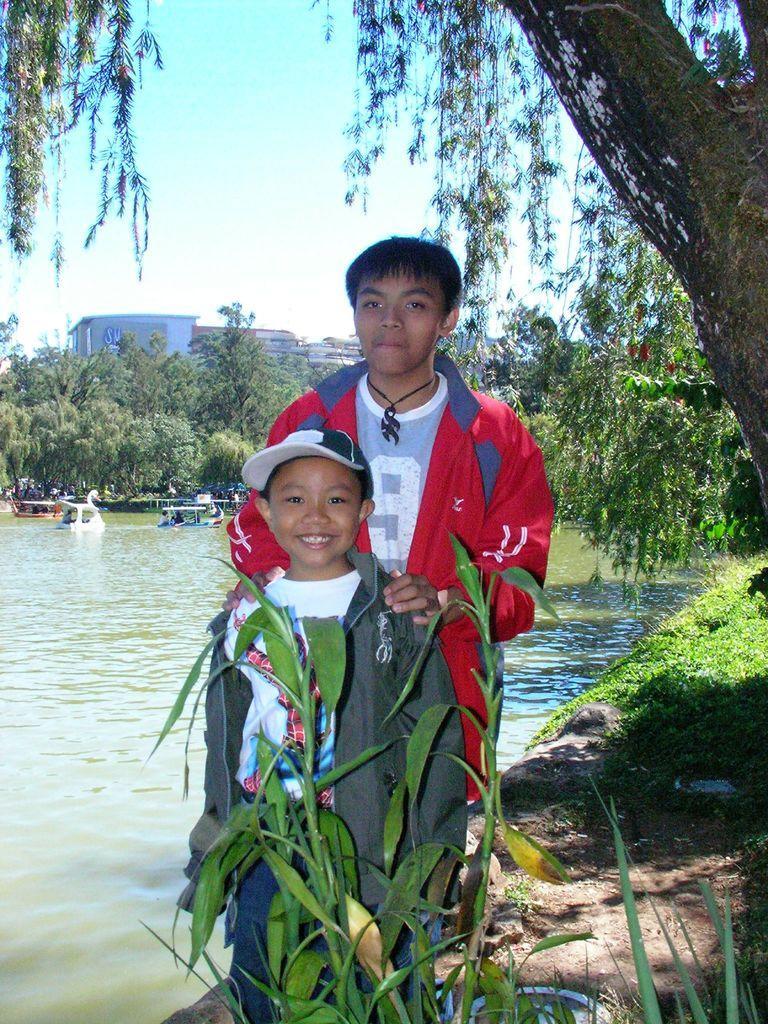Could you give a brief overview of what you see in this image? In the picture we can see two boys are standing together and one boy is smiling and he is with cap and behind them we can see grass surface and a tree and beside them we can see water and far away we can see some boats, trees, buildings, and behind it we can see a sky. 